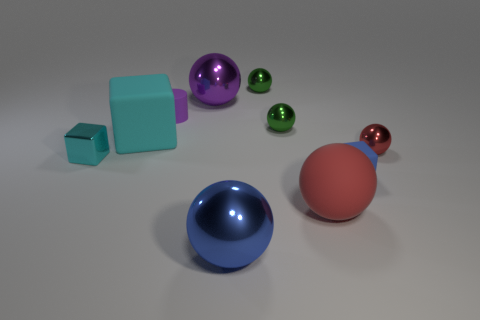There is another block that is the same color as the big rubber block; what material is it?
Your answer should be compact. Metal. Does the green thing behind the tiny purple matte object have the same material as the big sphere that is behind the blue rubber block?
Ensure brevity in your answer.  Yes. Are any big cyan rubber cubes visible?
Your answer should be compact. Yes. Is the number of rubber cylinders that are to the left of the cyan rubber thing greater than the number of spheres in front of the purple shiny thing?
Provide a short and direct response. No. There is another big cyan object that is the same shape as the cyan metallic thing; what material is it?
Offer a terse response. Rubber. Is there any other thing that has the same size as the blue rubber thing?
Provide a succinct answer. Yes. Does the tiny ball that is in front of the cyan matte block have the same color as the matte block that is on the right side of the cyan matte block?
Your answer should be very brief. No. What is the shape of the tiny red metal thing?
Provide a short and direct response. Sphere. Is the number of spheres that are behind the blue metallic thing greater than the number of things?
Offer a terse response. No. The shiny object to the right of the big matte sphere has what shape?
Your answer should be compact. Sphere. 